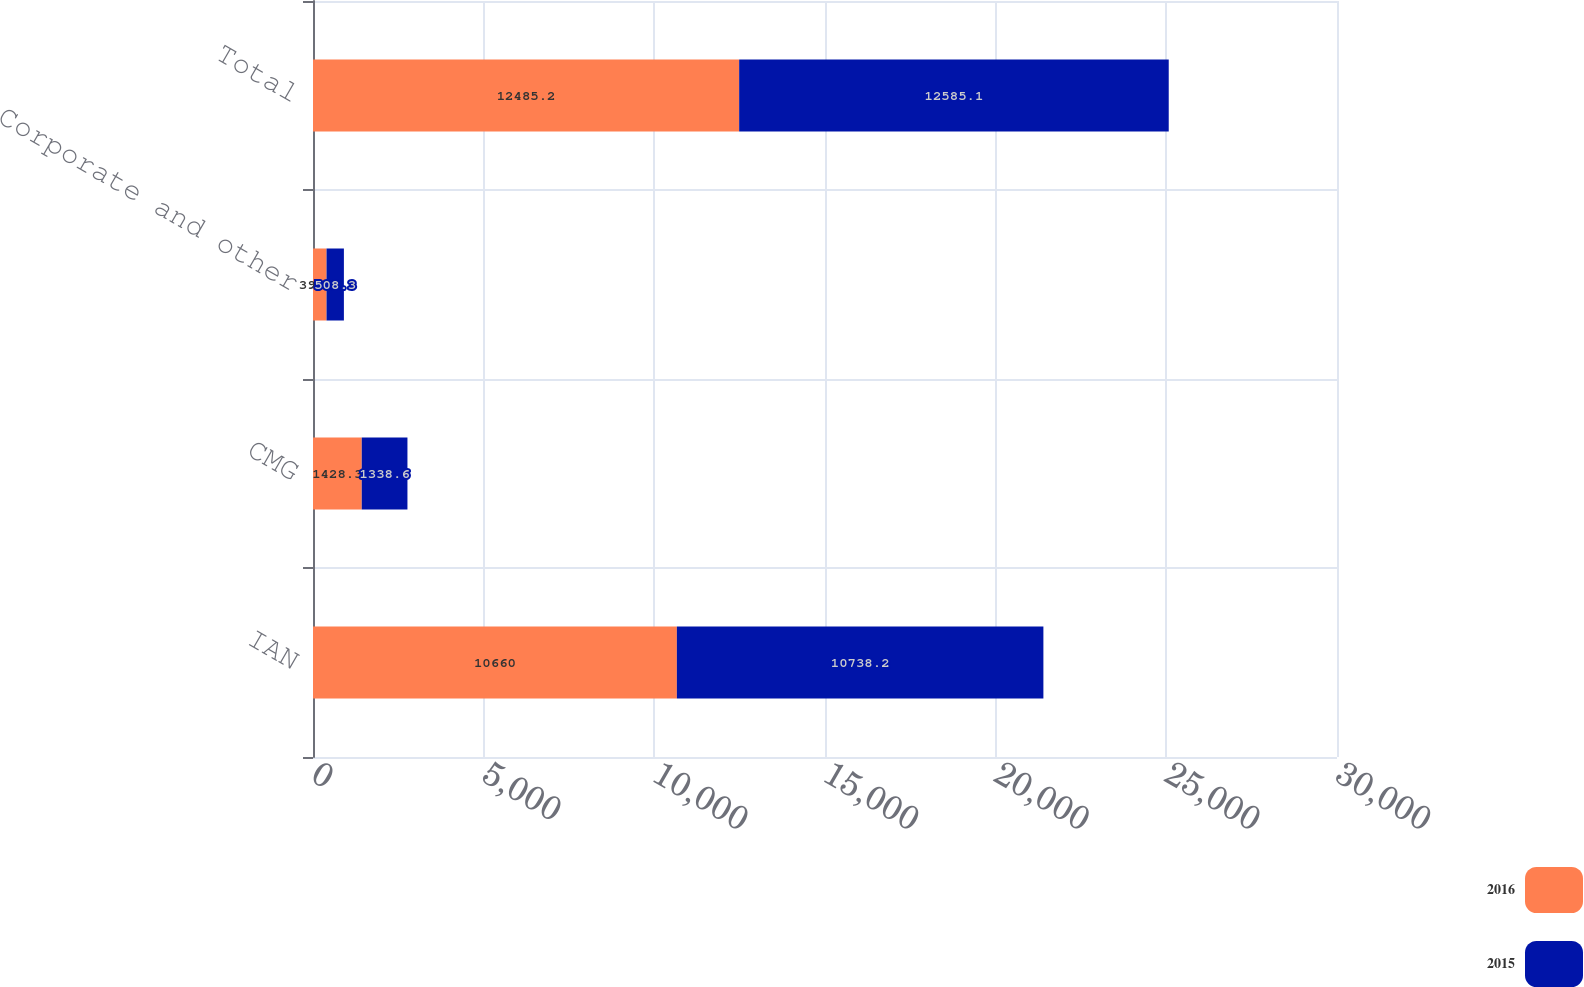Convert chart to OTSL. <chart><loc_0><loc_0><loc_500><loc_500><stacked_bar_chart><ecel><fcel>IAN<fcel>CMG<fcel>Corporate and other<fcel>Total<nl><fcel>2016<fcel>10660<fcel>1428.3<fcel>396.9<fcel>12485.2<nl><fcel>2015<fcel>10738.2<fcel>1338.6<fcel>508.3<fcel>12585.1<nl></chart> 